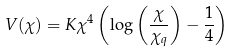Convert formula to latex. <formula><loc_0><loc_0><loc_500><loc_500>V ( \chi ) = K \chi ^ { 4 } \left ( \log \left ( \frac { \chi } { \chi _ { q } } \right ) - \frac { 1 } { 4 } \right )</formula> 